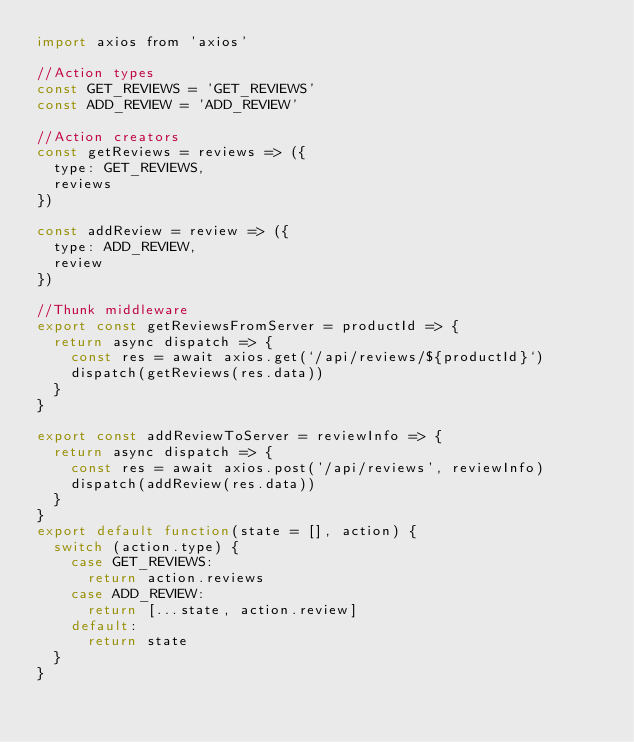<code> <loc_0><loc_0><loc_500><loc_500><_JavaScript_>import axios from 'axios'

//Action types
const GET_REVIEWS = 'GET_REVIEWS'
const ADD_REVIEW = 'ADD_REVIEW'

//Action creators
const getReviews = reviews => ({
	type: GET_REVIEWS,
	reviews
})

const addReview = review => ({
	type: ADD_REVIEW,
	review
})

//Thunk middleware
export const getReviewsFromServer = productId => {
	return async dispatch => {
		const res = await axios.get(`/api/reviews/${productId}`)
		dispatch(getReviews(res.data))
	}
}

export const addReviewToServer = reviewInfo => {
	return async dispatch => {
		const res = await axios.post('/api/reviews', reviewInfo)
		dispatch(addReview(res.data))
	}
}
export default function(state = [], action) {
	switch (action.type) {
		case GET_REVIEWS:
			return action.reviews
		case ADD_REVIEW:
			return [...state, action.review]
		default:
			return state
	}
}
</code> 